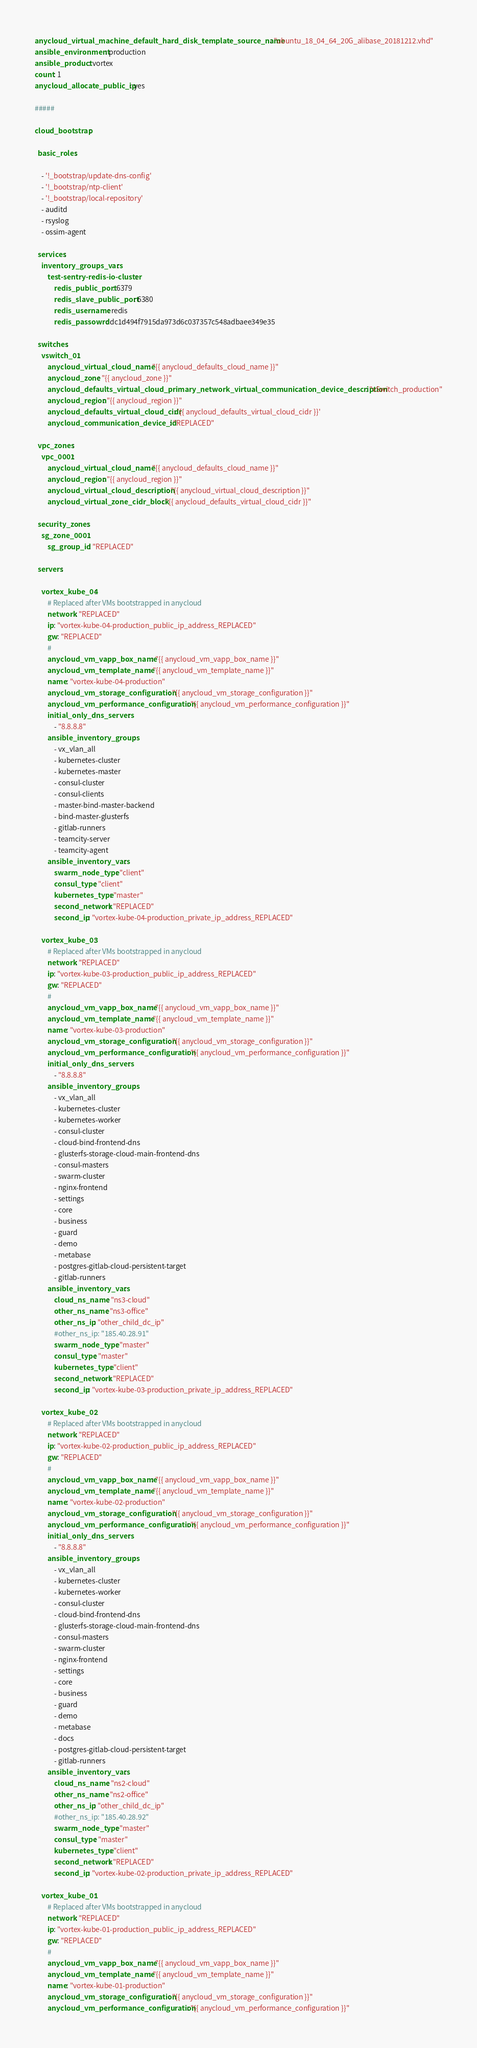Convert code to text. <code><loc_0><loc_0><loc_500><loc_500><_YAML_>anycloud_virtual_machine_default_hard_disk_template_source_name: "ubuntu_18_04_64_20G_alibase_20181212.vhd"
ansible_environment: production
ansible_product: vortex
count: 1
anycloud_allocate_public_ip: yes

#####

cloud_bootstrap:

  basic_roles:

    - '!_bootstrap/update-dns-config'
    - '!_bootstrap/ntp-client'
    - '!_bootstrap/local-repository'
    - auditd
    - rsyslog
    - ossim-agent

  services:
    inventory_groups_vars:
        test-sentry-redis-io-cluster:
            redis_public_port: 6379
            redis_slave_public_port: 6380
            redis_username: redis
            redis_passowrd: dc1d494f7915da973d6c037357c548adbaee349e35

  switches:
    vswitch_01:
        anycloud_virtual_cloud_name: "{{ anycloud_defaults_cloud_name }}"
        anycloud_zone: "{{ anycloud_zone }}"
        anycloud_defaults_virtual_cloud_primary_network_virtual_communication_device_description: "vSwitch_production"
        anycloud_region: "{{ anycloud_region }}"
        anycloud_defaults_virtual_cloud_cidr: '{{ anycloud_defaults_virtual_cloud_cidr }}'
        anycloud_communication_device_id: "REPLACED"

  vpc_zones:
    vpc_0001:
        anycloud_virtual_cloud_name: "{{ anycloud_defaults_cloud_name }}"
        anycloud_region: "{{ anycloud_region }}"
        anycloud_virtual_cloud_description: "{{ anycloud_virtual_cloud_description }}"
        anycloud_virtual_zone_cidr_block: "{{ anycloud_defaults_virtual_cloud_cidr }}"

  security_zones:
    sg_zone_0001:
        sg_group_id: "REPLACED"

  servers:

    vortex_kube_04:
        # Replaced after VMs bootstrapped in anycloud
        network: "REPLACED"
        ip: "vortex-kube-04-production_public_ip_address_REPLACED"
        gw: "REPLACED"
        #
        anycloud_vm_vapp_box_name: "{{ anycloud_vm_vapp_box_name }}"
        anycloud_vm_template_name: "{{ anycloud_vm_template_name }}"
        name: "vortex-kube-04-production"
        anycloud_vm_storage_configuration: "{{ anycloud_vm_storage_configuration }}"
        anycloud_vm_performance_configuration: "{{ anycloud_vm_performance_configuration }}"
        initial_only_dns_servers:
            - "8.8.8.8"
        ansible_inventory_groups:
            - vx_vlan_all
            - kubernetes-cluster
            - kubernetes-master
            - consul-cluster
            - consul-clients
            - master-bind-master-backend
            - bind-master-glusterfs
            - gitlab-runners
            - teamcity-server
            - teamcity-agent
        ansible_inventory_vars:
            swarm_node_type: "client"
            consul_type: "client"
            kubernetes_type: "master"
            second_network: "REPLACED"
            second_ip: "vortex-kube-04-production_private_ip_address_REPLACED"

    vortex_kube_03:
        # Replaced after VMs bootstrapped in anycloud
        network: "REPLACED"
        ip: "vortex-kube-03-production_public_ip_address_REPLACED"
        gw: "REPLACED"
        #
        anycloud_vm_vapp_box_name: "{{ anycloud_vm_vapp_box_name }}"
        anycloud_vm_template_name: "{{ anycloud_vm_template_name }}"
        name: "vortex-kube-03-production"
        anycloud_vm_storage_configuration: "{{ anycloud_vm_storage_configuration }}"
        anycloud_vm_performance_configuration: "{{ anycloud_vm_performance_configuration }}"
        initial_only_dns_servers:
            - "8.8.8.8"
        ansible_inventory_groups:
            - vx_vlan_all
            - kubernetes-cluster
            - kubernetes-worker
            - consul-cluster
            - cloud-bind-frontend-dns
            - glusterfs-storage-cloud-main-frontend-dns
            - consul-masters
            - swarm-cluster
            - nginx-frontend
            - settings
            - core
            - business
            - guard
            - demo
            - metabase
            - postgres-gitlab-cloud-persistent-target
            - gitlab-runners
        ansible_inventory_vars:
            cloud_ns_name: "ns3-cloud"
            other_ns_name: "ns3-office"
            other_ns_ip: "other_child_dc_ip"
            #other_ns_ip: "185.40.28.91"
            swarm_node_type: "master"
            consul_type: "master"
            kubernetes_type: "client"
            second_network: "REPLACED"
            second_ip: "vortex-kube-03-production_private_ip_address_REPLACED"

    vortex_kube_02:
        # Replaced after VMs bootstrapped in anycloud
        network: "REPLACED"
        ip: "vortex-kube-02-production_public_ip_address_REPLACED"
        gw: "REPLACED"
        #
        anycloud_vm_vapp_box_name: "{{ anycloud_vm_vapp_box_name }}"
        anycloud_vm_template_name: "{{ anycloud_vm_template_name }}"
        name: "vortex-kube-02-production"
        anycloud_vm_storage_configuration: "{{ anycloud_vm_storage_configuration }}"
        anycloud_vm_performance_configuration: "{{ anycloud_vm_performance_configuration }}"
        initial_only_dns_servers:
            - "8.8.8.8"
        ansible_inventory_groups:
            - vx_vlan_all
            - kubernetes-cluster
            - kubernetes-worker
            - consul-cluster
            - cloud-bind-frontend-dns
            - glusterfs-storage-cloud-main-frontend-dns
            - consul-masters
            - swarm-cluster
            - nginx-frontend
            - settings
            - core
            - business
            - guard
            - demo
            - metabase
            - docs
            - postgres-gitlab-cloud-persistent-target
            - gitlab-runners
        ansible_inventory_vars:
            cloud_ns_name: "ns2-cloud"
            other_ns_name: "ns2-office"
            other_ns_ip: "other_child_dc_ip"
            #other_ns_ip: "185.40.28.92"
            swarm_node_type: "master"
            consul_type: "master"
            kubernetes_type: "client"
            second_network: "REPLACED"
            second_ip: "vortex-kube-02-production_private_ip_address_REPLACED"

    vortex_kube_01:
        # Replaced after VMs bootstrapped in anycloud
        network: "REPLACED"
        ip: "vortex-kube-01-production_public_ip_address_REPLACED"
        gw: "REPLACED"
        #
        anycloud_vm_vapp_box_name: "{{ anycloud_vm_vapp_box_name }}"
        anycloud_vm_template_name: "{{ anycloud_vm_template_name }}"
        name: "vortex-kube-01-production"
        anycloud_vm_storage_configuration: "{{ anycloud_vm_storage_configuration }}"
        anycloud_vm_performance_configuration: "{{ anycloud_vm_performance_configuration }}"</code> 